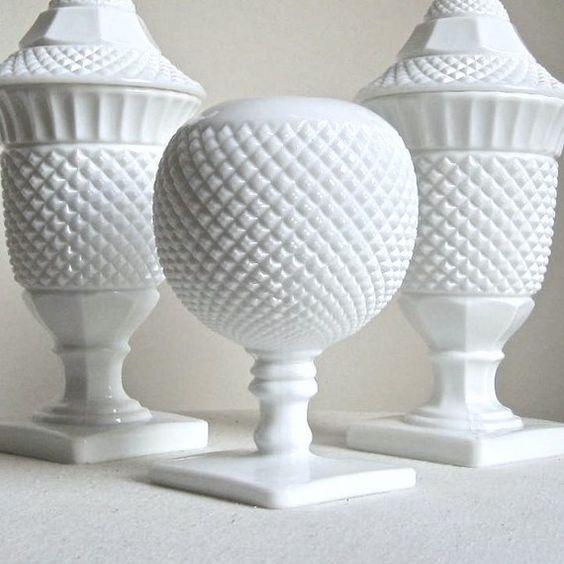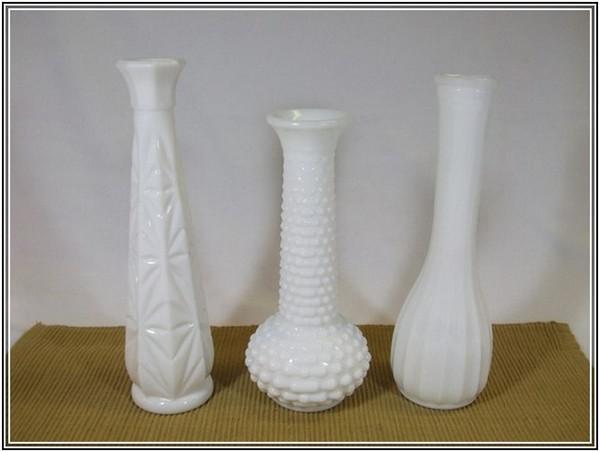The first image is the image on the left, the second image is the image on the right. Considering the images on both sides, is "There is no more than three sculptures in the left image." valid? Answer yes or no. Yes. The first image is the image on the left, the second image is the image on the right. Considering the images on both sides, is "There are at most six vases." valid? Answer yes or no. Yes. 